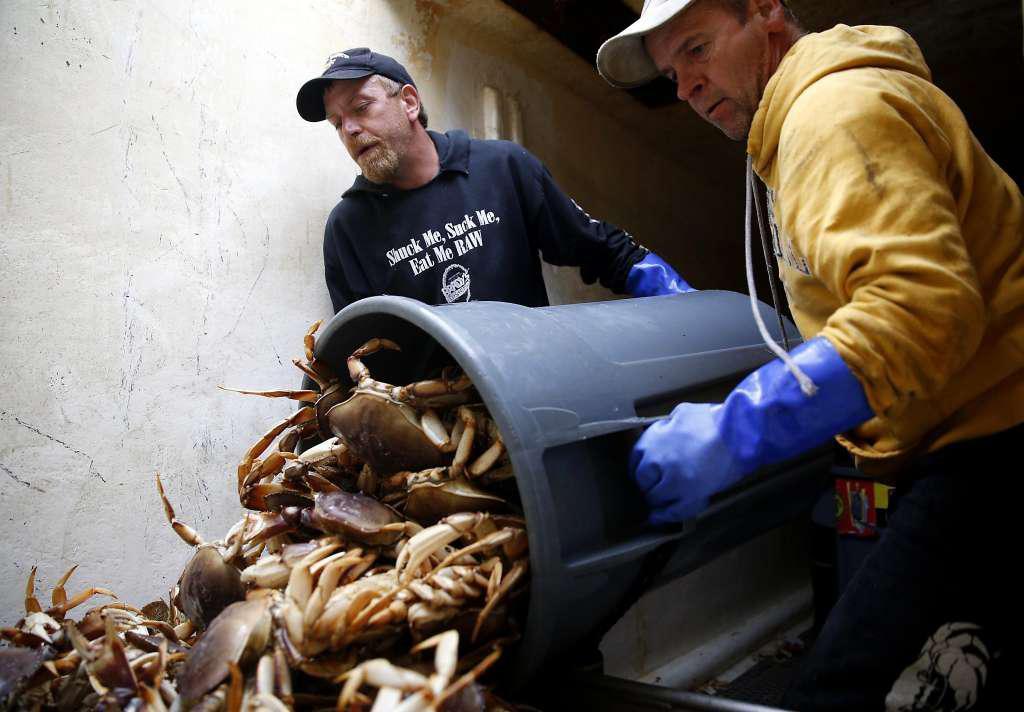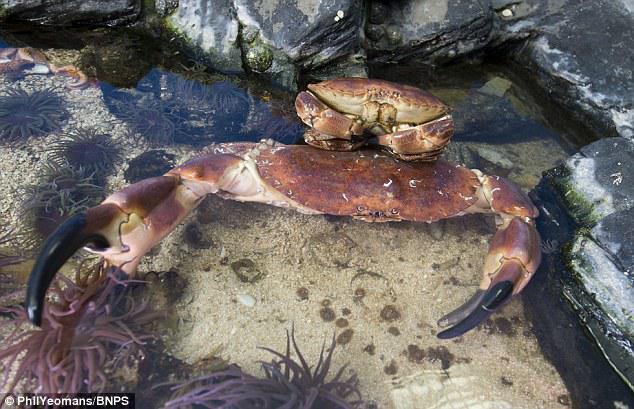The first image is the image on the left, the second image is the image on the right. For the images displayed, is the sentence "Each image shows purplish-gray crabs in a container made of mesh attached to a frame." factually correct? Answer yes or no. No. The first image is the image on the left, the second image is the image on the right. Analyze the images presented: Is the assertion "At least one crab is in the wild." valid? Answer yes or no. Yes. 